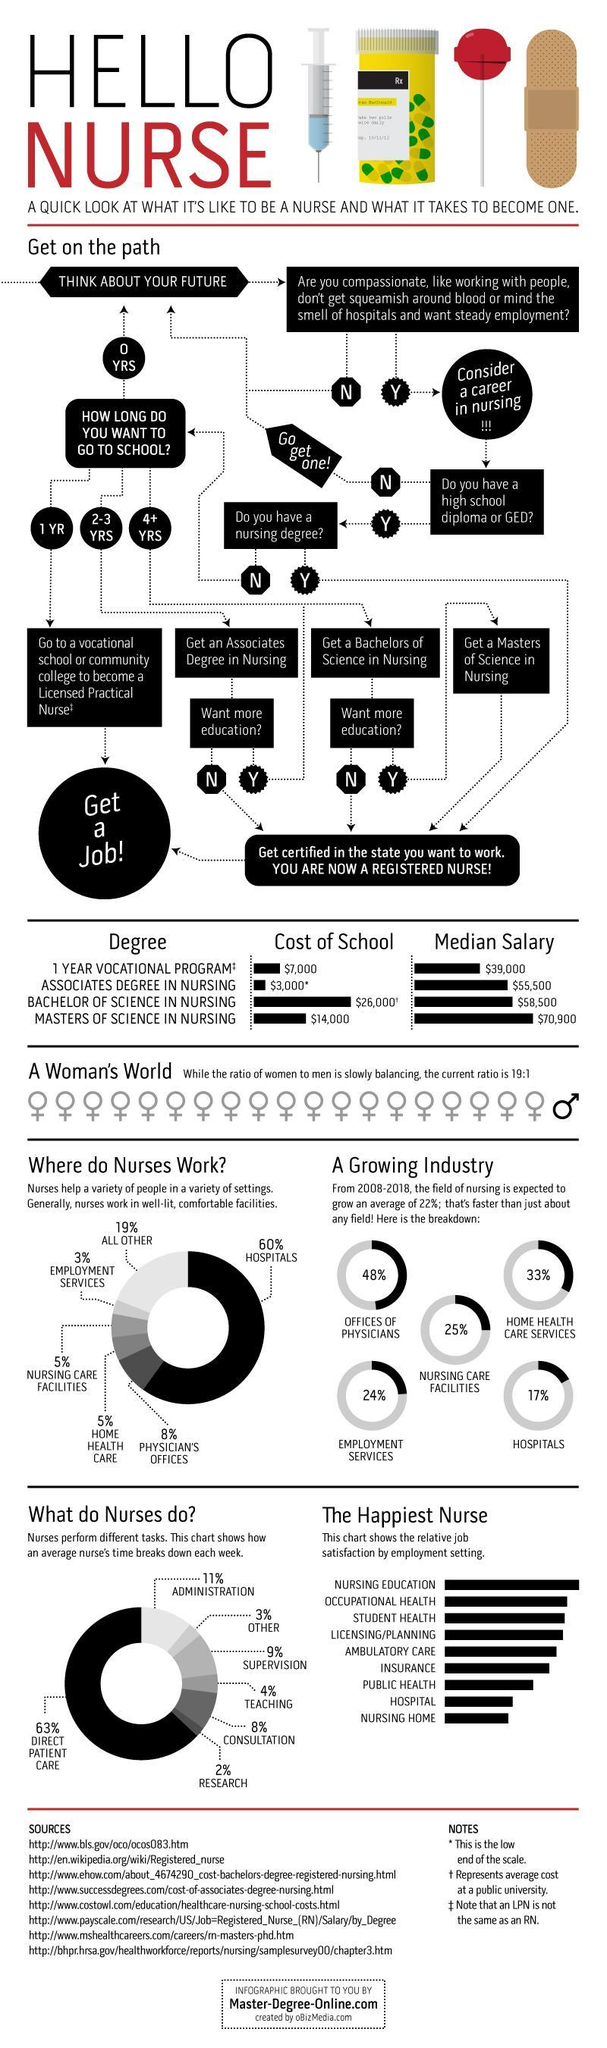What is the percentage of teaching and consultation when taken together?
Answer the question with a short phrase. 11% Which type of work has the highest share? Hospitals Which task of the nurse has the highest share? Direct Patient Care 